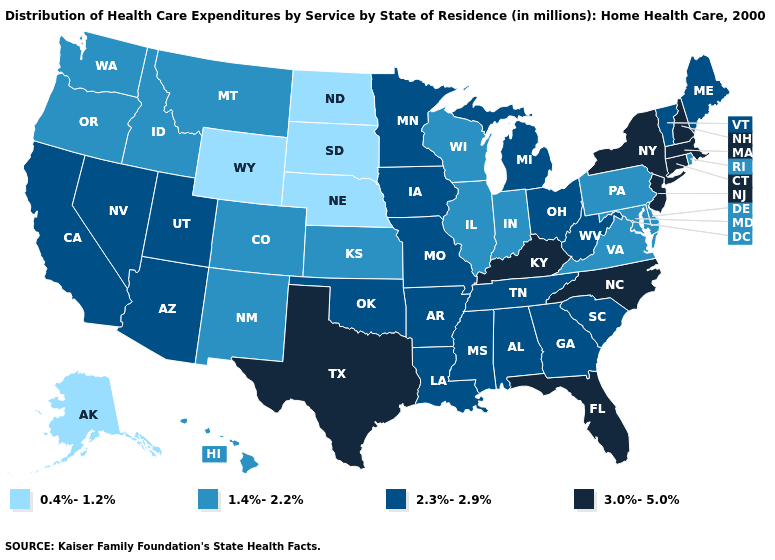Name the states that have a value in the range 2.3%-2.9%?
Concise answer only. Alabama, Arizona, Arkansas, California, Georgia, Iowa, Louisiana, Maine, Michigan, Minnesota, Mississippi, Missouri, Nevada, Ohio, Oklahoma, South Carolina, Tennessee, Utah, Vermont, West Virginia. Does West Virginia have the lowest value in the USA?
Be succinct. No. What is the lowest value in the South?
Answer briefly. 1.4%-2.2%. What is the value of Ohio?
Keep it brief. 2.3%-2.9%. Does the first symbol in the legend represent the smallest category?
Keep it brief. Yes. Does Pennsylvania have the lowest value in the Northeast?
Give a very brief answer. Yes. Which states have the lowest value in the West?
Give a very brief answer. Alaska, Wyoming. Name the states that have a value in the range 3.0%-5.0%?
Be succinct. Connecticut, Florida, Kentucky, Massachusetts, New Hampshire, New Jersey, New York, North Carolina, Texas. What is the value of South Dakota?
Short answer required. 0.4%-1.2%. Among the states that border Virginia , which have the lowest value?
Answer briefly. Maryland. Name the states that have a value in the range 3.0%-5.0%?
Write a very short answer. Connecticut, Florida, Kentucky, Massachusetts, New Hampshire, New Jersey, New York, North Carolina, Texas. What is the value of Utah?
Answer briefly. 2.3%-2.9%. Does Rhode Island have the highest value in the Northeast?
Concise answer only. No. What is the lowest value in the West?
Answer briefly. 0.4%-1.2%. What is the value of Arkansas?
Short answer required. 2.3%-2.9%. 